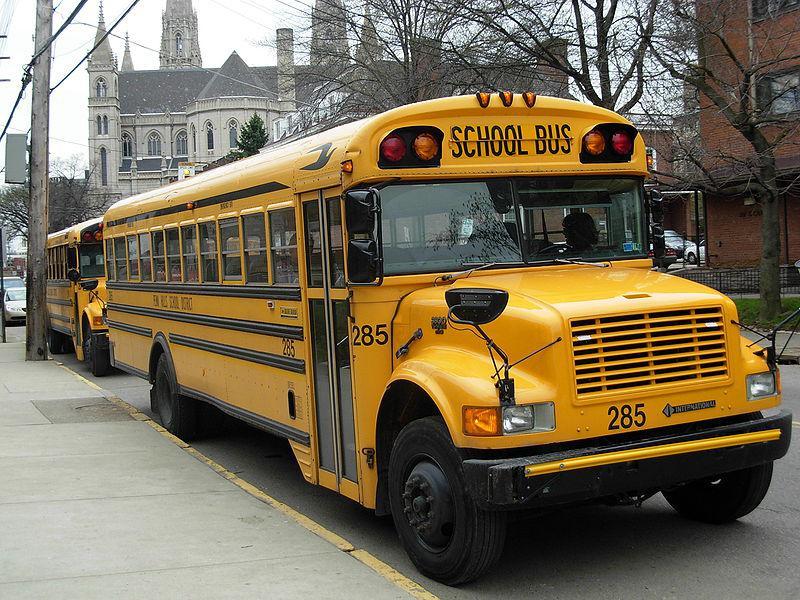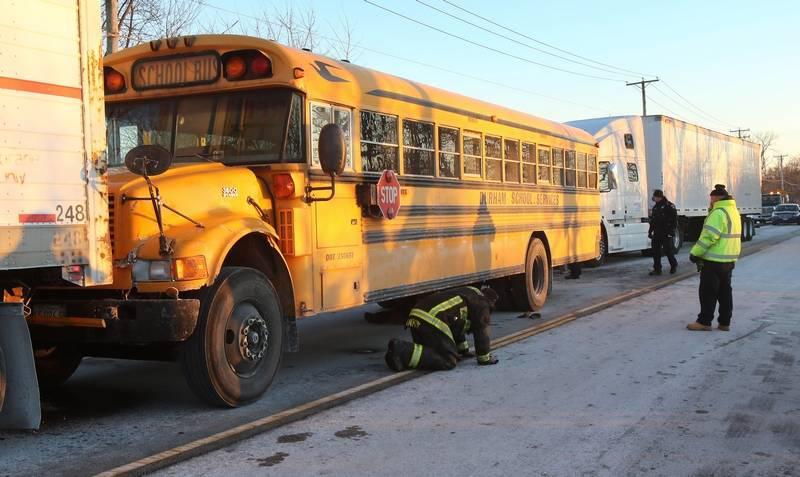The first image is the image on the left, the second image is the image on the right. Examine the images to the left and right. Is the description "In the image to the right, at least one person is standing in front of the open door to the bus." accurate? Answer yes or no. No. The first image is the image on the left, the second image is the image on the right. Examine the images to the left and right. Is the description "One image shows one forward-facing flat-fronted bus with at least one person standing at the left, door side, and the other image shows a forward-facing non-flat-front bus with at least one person standing at the left, door side." accurate? Answer yes or no. No. 